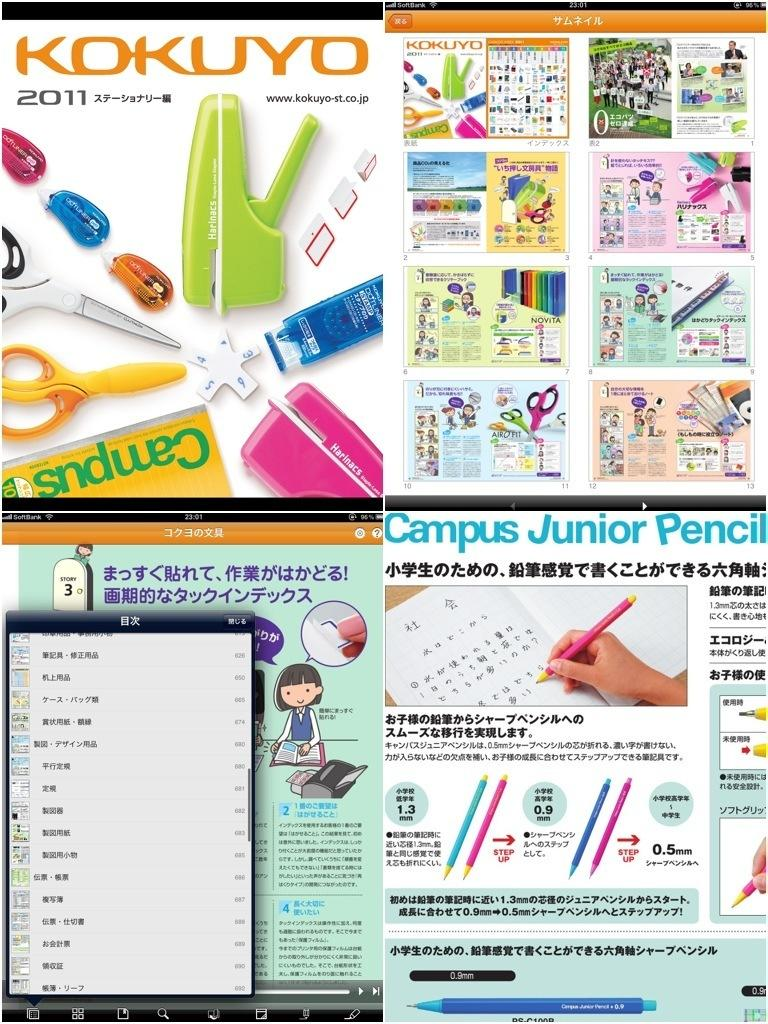<image>
Write a terse but informative summary of the picture. Kokuyo 2011 shows advertisements for school supplies such as Campus Junior Pencil. 